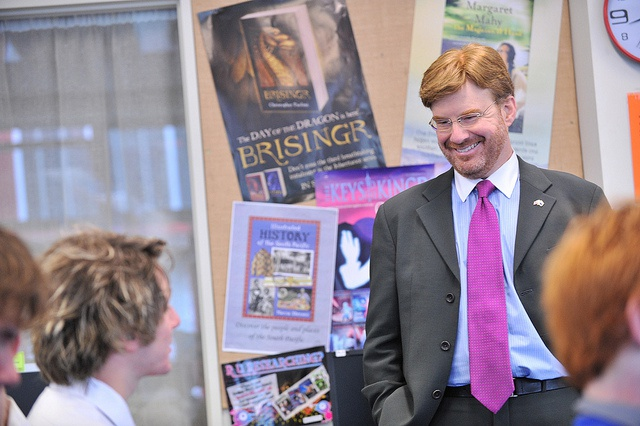Describe the objects in this image and their specific colors. I can see people in darkgray, gray, black, and lavender tones, people in darkgray, gray, and lavender tones, people in darkgray, brown, salmon, and maroon tones, tie in darkgray, magenta, and purple tones, and people in darkgray, brown, gray, and maroon tones in this image. 